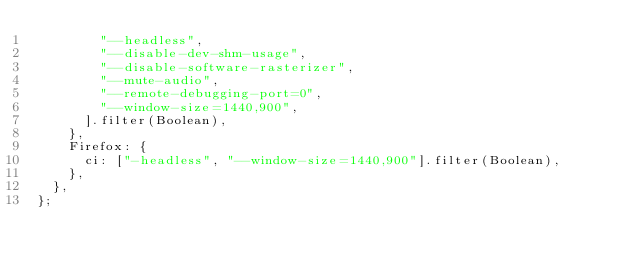Convert code to text. <code><loc_0><loc_0><loc_500><loc_500><_JavaScript_>        "--headless",
        "--disable-dev-shm-usage",
        "--disable-software-rasterizer",
        "--mute-audio",
        "--remote-debugging-port=0",
        "--window-size=1440,900",
      ].filter(Boolean),
    },
    Firefox: {
      ci: ["-headless", "--window-size=1440,900"].filter(Boolean),
    },
  },
};
</code> 